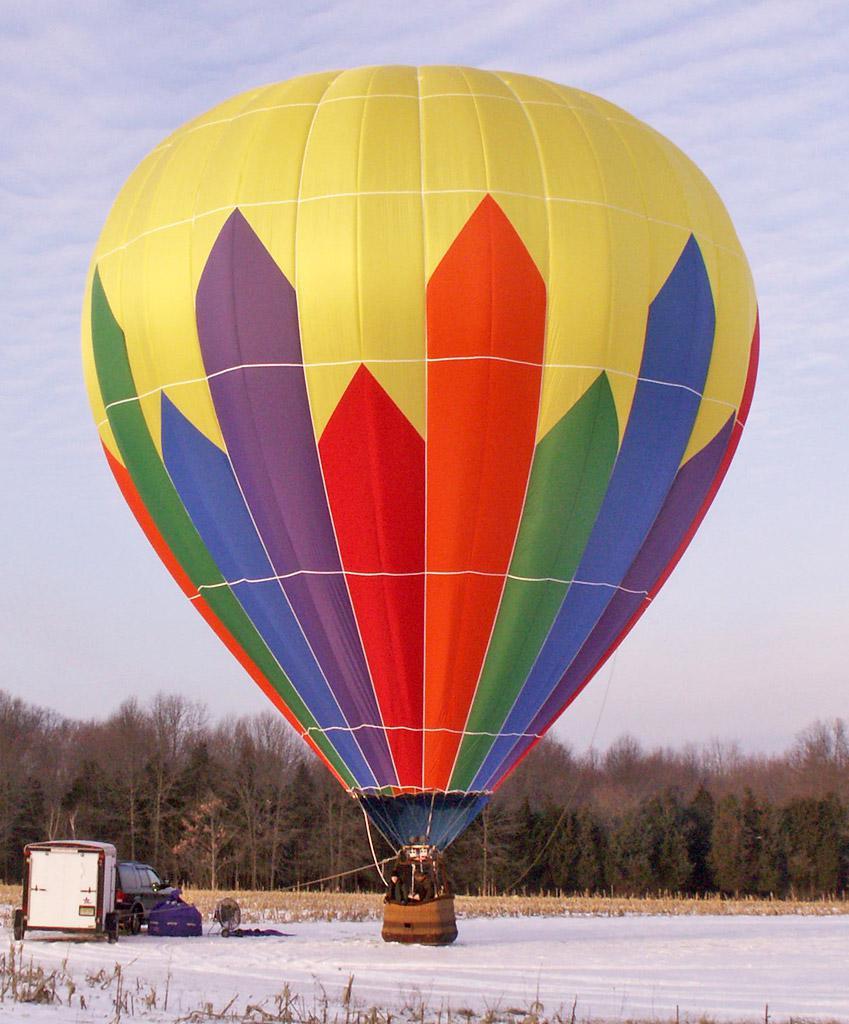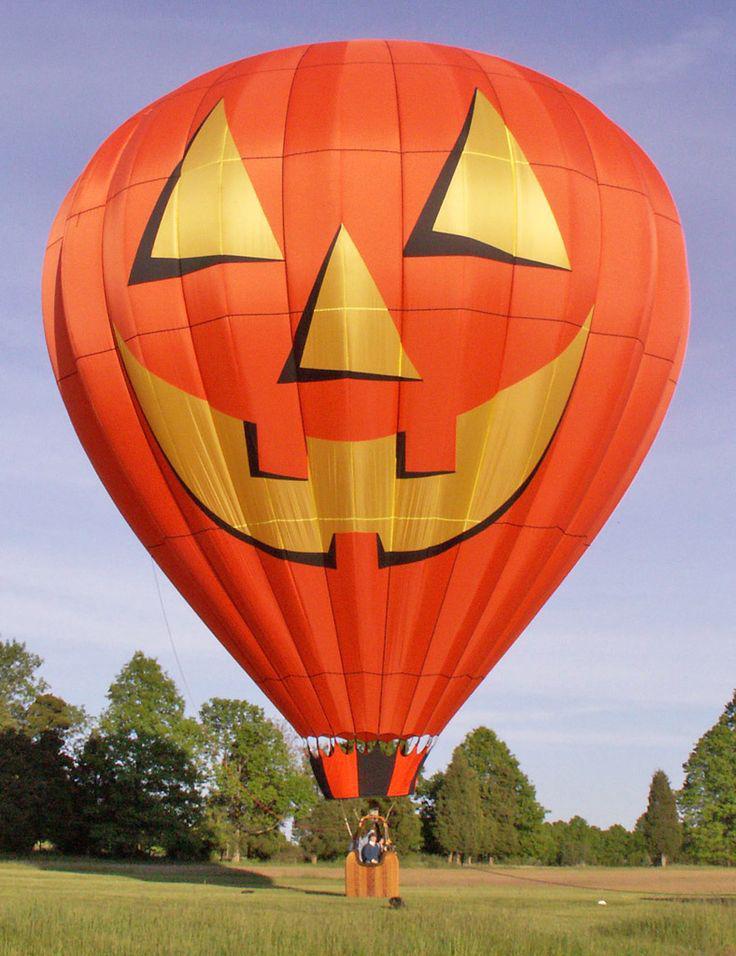The first image is the image on the left, the second image is the image on the right. Given the left and right images, does the statement "One of the balloons has a face depicted on it." hold true? Answer yes or no. Yes. 